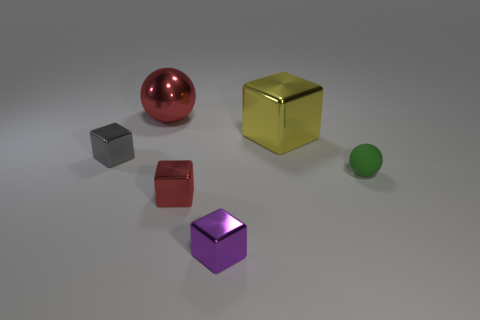Subtract 1 blocks. How many blocks are left? 3 Add 2 gray blocks. How many objects exist? 8 Subtract all balls. How many objects are left? 4 Subtract all rubber objects. Subtract all big yellow objects. How many objects are left? 4 Add 2 small red shiny blocks. How many small red shiny blocks are left? 3 Add 1 small purple shiny balls. How many small purple shiny balls exist? 1 Subtract 0 purple balls. How many objects are left? 6 